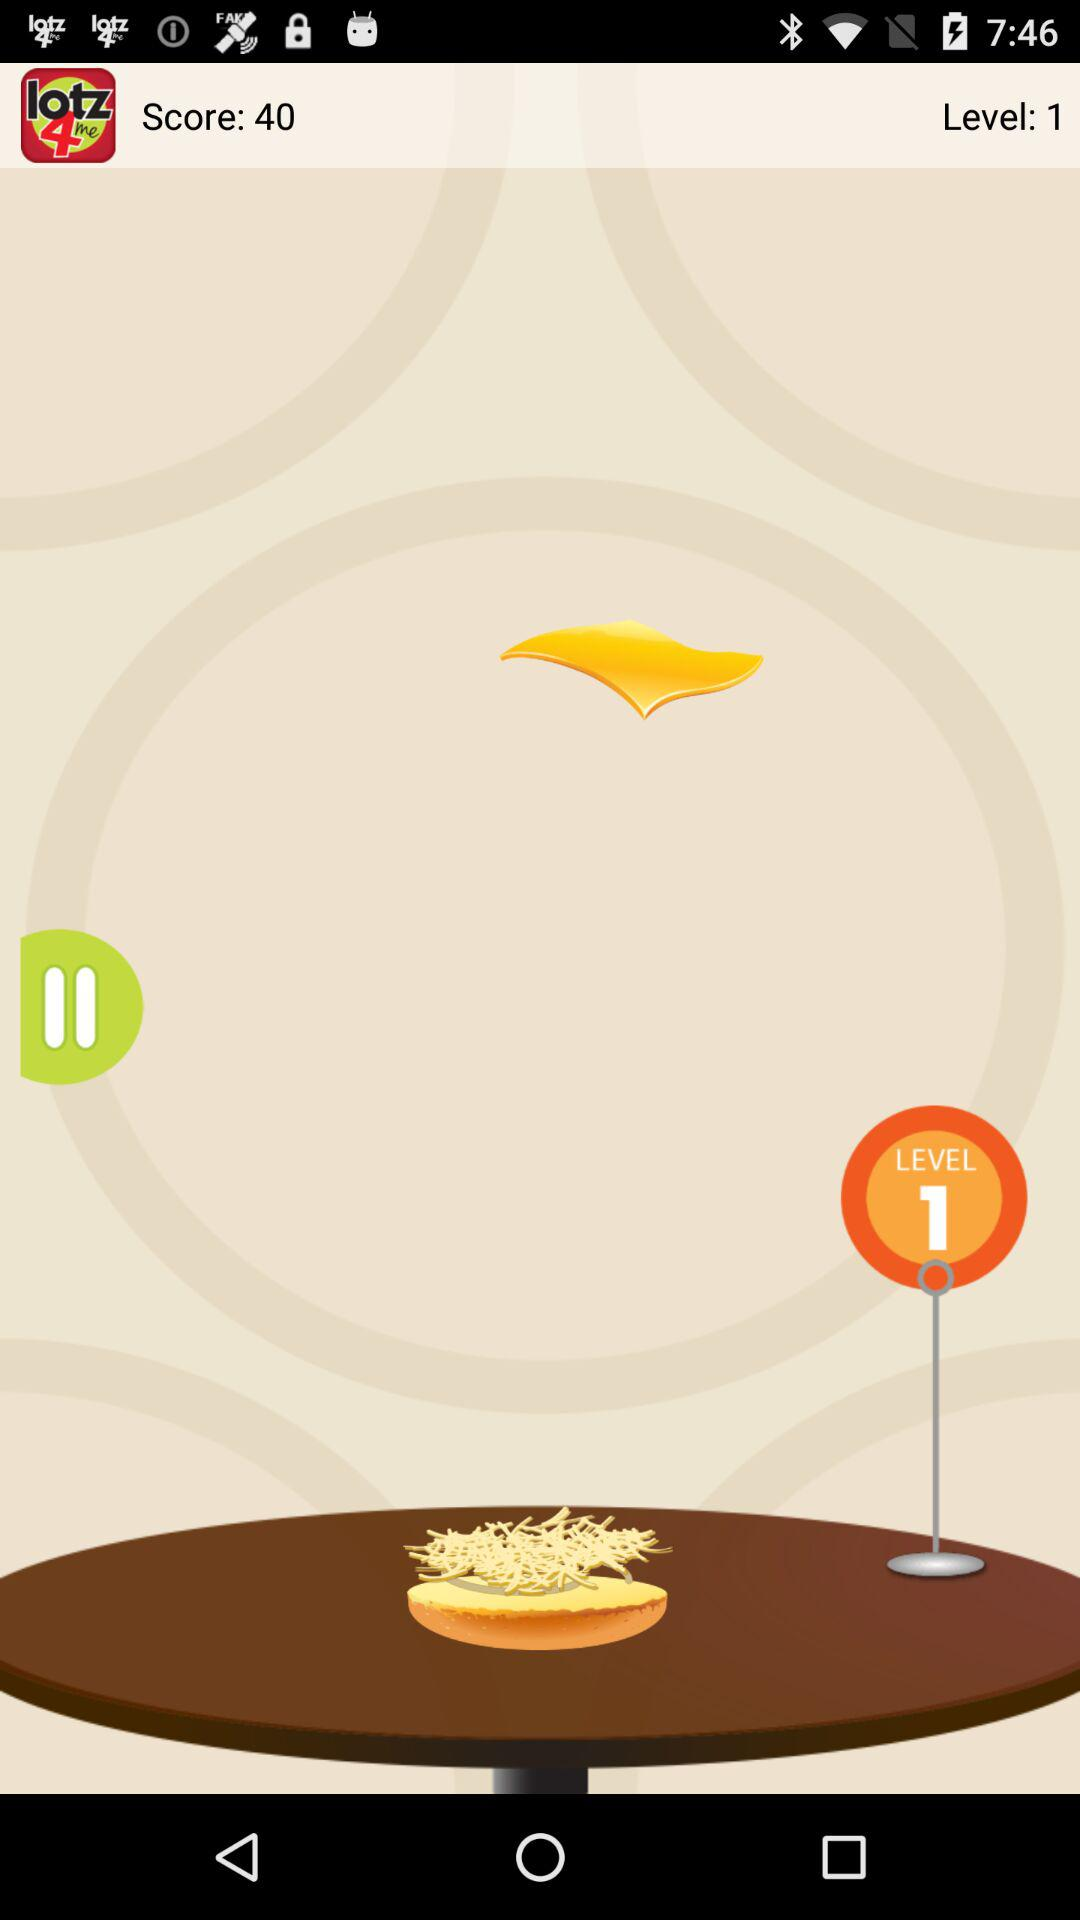What is the application name? The application name is "Schlotzsky's Rewards Program". 